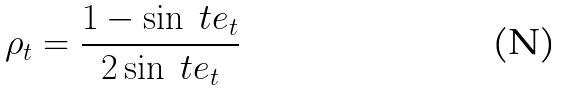Convert formula to latex. <formula><loc_0><loc_0><loc_500><loc_500>\rho _ { t } = \frac { 1 - \sin \ t e _ { t } } { 2 \sin \ t e _ { t } }</formula> 